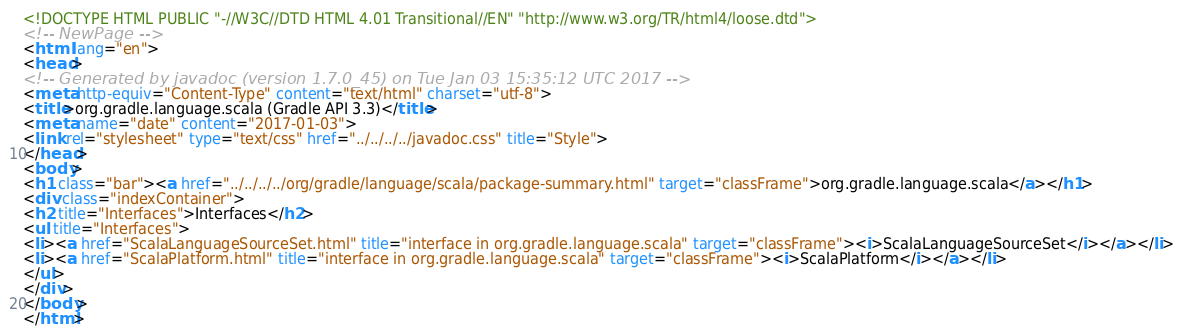Convert code to text. <code><loc_0><loc_0><loc_500><loc_500><_HTML_><!DOCTYPE HTML PUBLIC "-//W3C//DTD HTML 4.01 Transitional//EN" "http://www.w3.org/TR/html4/loose.dtd">
<!-- NewPage -->
<html lang="en">
<head>
<!-- Generated by javadoc (version 1.7.0_45) on Tue Jan 03 15:35:12 UTC 2017 -->
<meta http-equiv="Content-Type" content="text/html" charset="utf-8">
<title>org.gradle.language.scala (Gradle API 3.3)</title>
<meta name="date" content="2017-01-03">
<link rel="stylesheet" type="text/css" href="../../../../javadoc.css" title="Style">
</head>
<body>
<h1 class="bar"><a href="../../../../org/gradle/language/scala/package-summary.html" target="classFrame">org.gradle.language.scala</a></h1>
<div class="indexContainer">
<h2 title="Interfaces">Interfaces</h2>
<ul title="Interfaces">
<li><a href="ScalaLanguageSourceSet.html" title="interface in org.gradle.language.scala" target="classFrame"><i>ScalaLanguageSourceSet</i></a></li>
<li><a href="ScalaPlatform.html" title="interface in org.gradle.language.scala" target="classFrame"><i>ScalaPlatform</i></a></li>
</ul>
</div>
</body>
</html>
</code> 